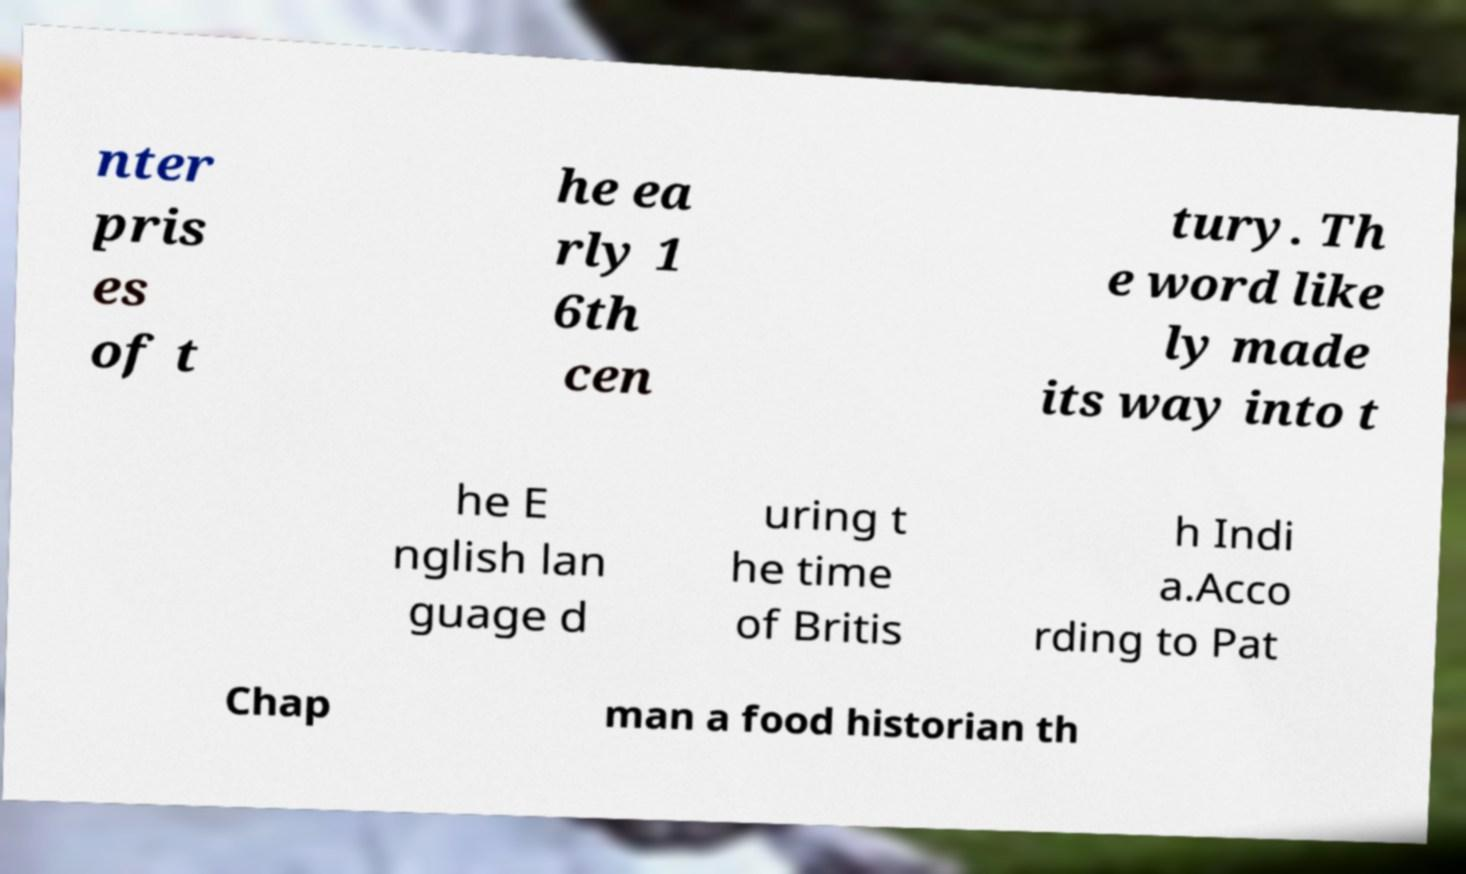I need the written content from this picture converted into text. Can you do that? nter pris es of t he ea rly 1 6th cen tury. Th e word like ly made its way into t he E nglish lan guage d uring t he time of Britis h Indi a.Acco rding to Pat Chap man a food historian th 